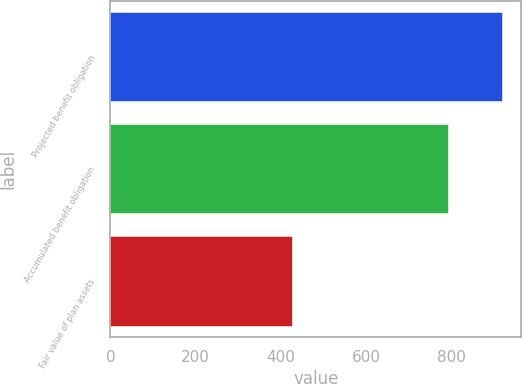Convert chart. <chart><loc_0><loc_0><loc_500><loc_500><bar_chart><fcel>Projected benefit obligation<fcel>Accumulated benefit obligation<fcel>Fair value of plan assets<nl><fcel>918<fcel>791<fcel>427<nl></chart> 